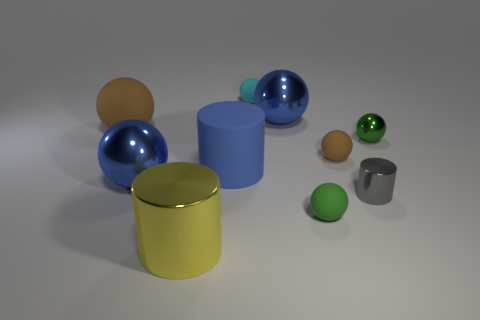Are there more tiny cyan balls that are left of the blue cylinder than brown rubber balls that are behind the small green rubber thing?
Your answer should be compact. No. There is a big matte object on the left side of the blue cylinder; is it the same color as the rubber thing in front of the large blue cylinder?
Keep it short and to the point. No. What is the shape of the other metallic object that is the same size as the gray object?
Provide a succinct answer. Sphere. Is there a tiny blue metallic object of the same shape as the tiny gray object?
Provide a short and direct response. No. Is the small cyan thing that is behind the large rubber cylinder made of the same material as the green object that is in front of the tiny green shiny sphere?
Offer a terse response. Yes. The rubber object that is the same color as the large rubber ball is what shape?
Provide a short and direct response. Sphere. What number of yellow things are the same material as the gray cylinder?
Provide a succinct answer. 1. The tiny metallic ball is what color?
Your response must be concise. Green. Does the big blue metallic object that is to the left of the big shiny cylinder have the same shape as the brown object that is on the left side of the blue cylinder?
Your answer should be compact. Yes. There is a large cylinder behind the tiny gray metallic object; what is its color?
Provide a succinct answer. Blue. 